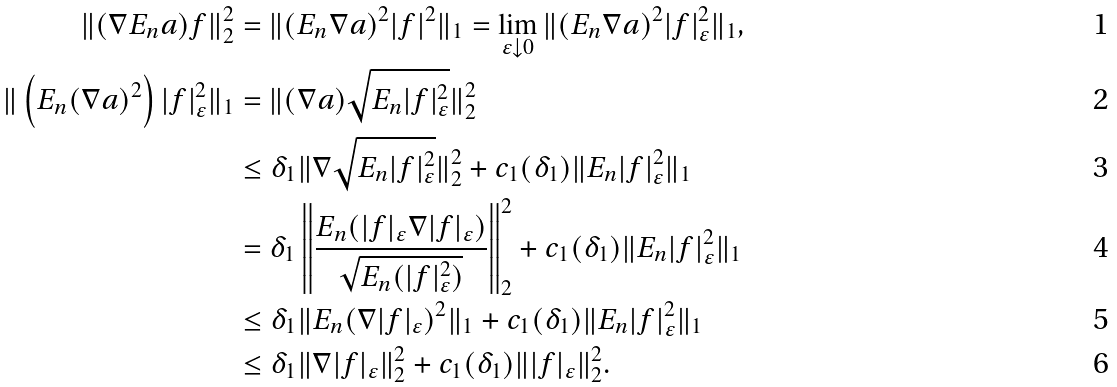<formula> <loc_0><loc_0><loc_500><loc_500>\| ( \nabla E _ { n } a ) f \| _ { 2 } ^ { 2 } & = \| ( E _ { n } \nabla a ) ^ { 2 } | f | ^ { 2 } \| _ { 1 } = \lim _ { \varepsilon \downarrow 0 } \| ( E _ { n } \nabla a ) ^ { 2 } | f | _ { \varepsilon } ^ { 2 } \| _ { 1 } , \\ \| \left ( E _ { n } ( \nabla a ) ^ { 2 } \right ) | f | _ { \varepsilon } ^ { 2 } \| _ { 1 } & = \| ( \nabla a ) \sqrt { E _ { n } | f | _ { \varepsilon } ^ { 2 } } \| _ { 2 } ^ { 2 } \\ & \leq \delta _ { 1 } \| \nabla \sqrt { E _ { n } | f | _ { \varepsilon } ^ { 2 } } \| _ { 2 } ^ { 2 } + c _ { 1 } ( \delta _ { 1 } ) \| E _ { n } | f | _ { \varepsilon } ^ { 2 } \| _ { 1 } \\ & = \delta _ { 1 } \left \| \frac { E _ { n } ( | f | _ { \varepsilon } \nabla | f | _ { \varepsilon } ) } { \sqrt { E _ { n } ( | f | _ { \varepsilon } ^ { 2 } ) } } \right \| _ { 2 } ^ { 2 } + c _ { 1 } ( \delta _ { 1 } ) \| E _ { n } | f | _ { \varepsilon } ^ { 2 } \| _ { 1 } \\ & \leq \delta _ { 1 } \| E _ { n } ( \nabla | f | _ { \varepsilon } ) ^ { 2 } \| _ { 1 } + c _ { 1 } ( \delta _ { 1 } ) \| E _ { n } | f | _ { \varepsilon } ^ { 2 } \| _ { 1 } \\ & \leq \delta _ { 1 } \| \nabla | f | _ { \varepsilon } \| _ { 2 } ^ { 2 } + c _ { 1 } ( \delta _ { 1 } ) \| | f | _ { \varepsilon } \| _ { 2 } ^ { 2 } .</formula> 